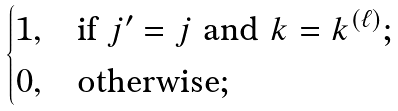<formula> <loc_0><loc_0><loc_500><loc_500>\begin{cases} 1 , & \text {if } j ^ { \prime } = j \text { and } k = k ^ { ( \ell ) } ; \\ 0 , & \text {otherwise} ; \end{cases}</formula> 